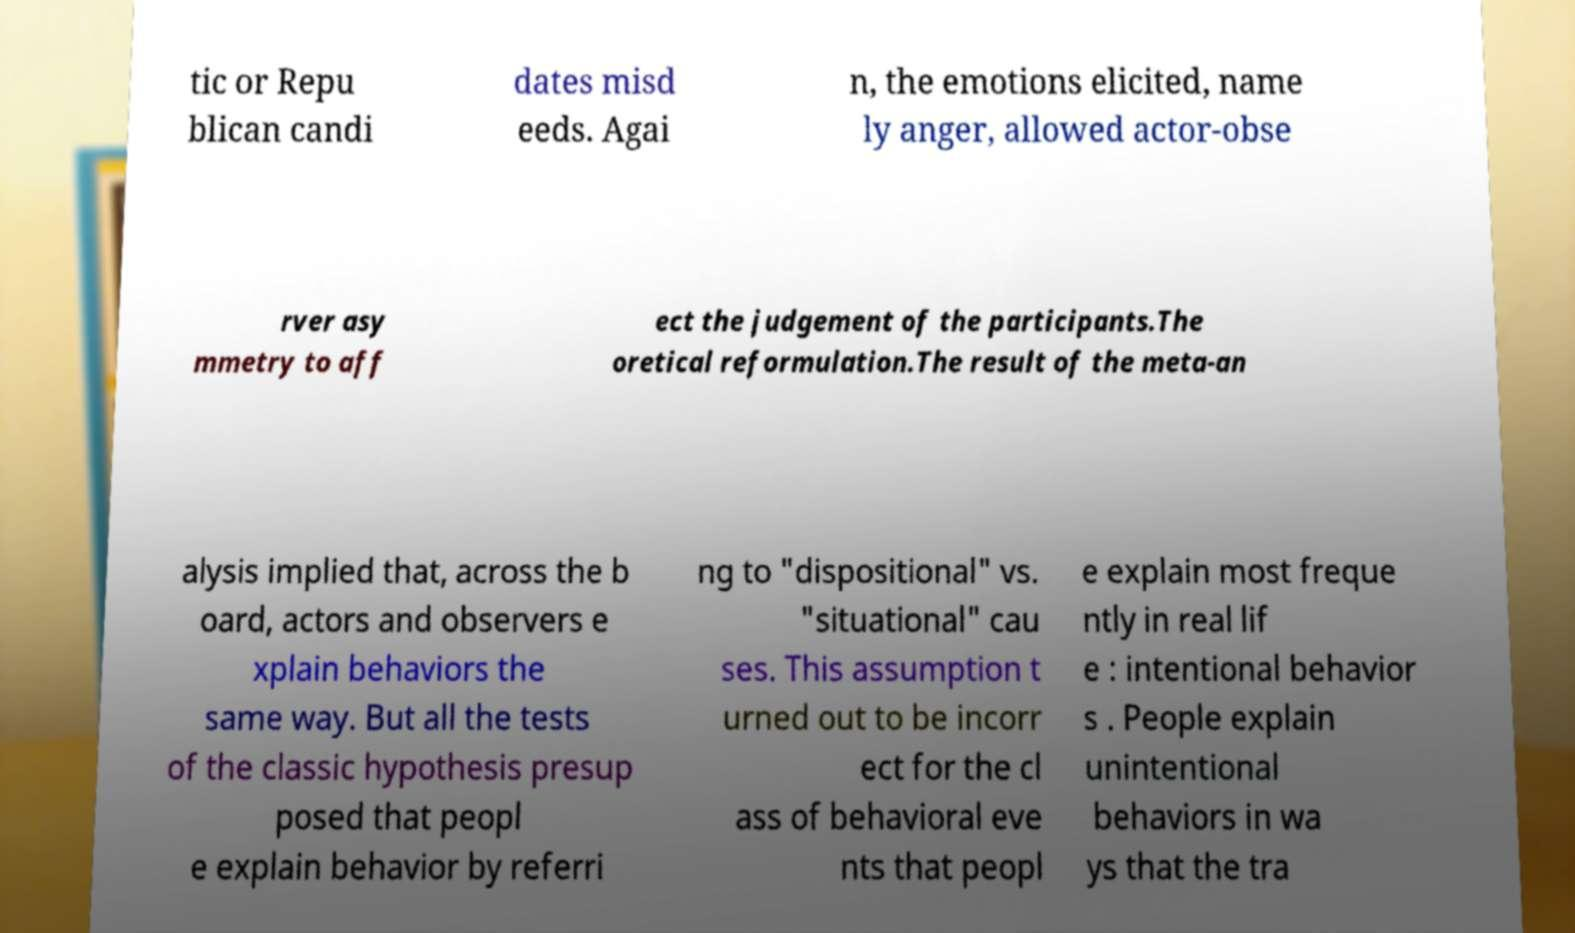Could you extract and type out the text from this image? tic or Repu blican candi dates misd eeds. Agai n, the emotions elicited, name ly anger, allowed actor-obse rver asy mmetry to aff ect the judgement of the participants.The oretical reformulation.The result of the meta-an alysis implied that, across the b oard, actors and observers e xplain behaviors the same way. But all the tests of the classic hypothesis presup posed that peopl e explain behavior by referri ng to "dispositional" vs. "situational" cau ses. This assumption t urned out to be incorr ect for the cl ass of behavioral eve nts that peopl e explain most freque ntly in real lif e : intentional behavior s . People explain unintentional behaviors in wa ys that the tra 